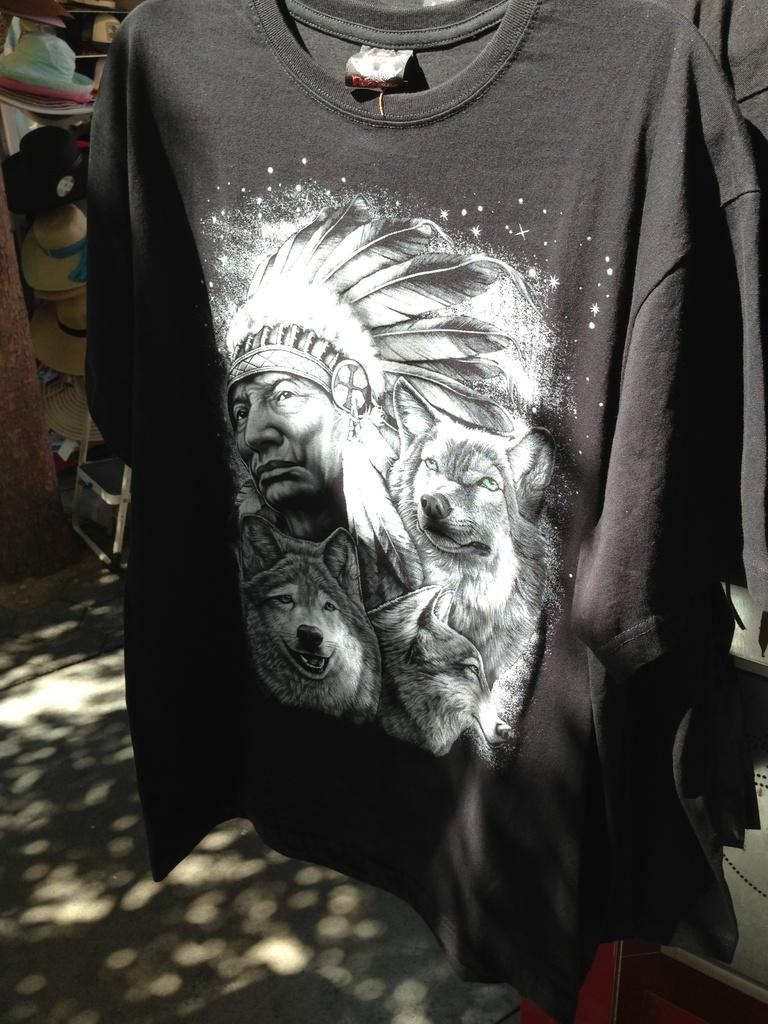What is featured on the t-shirt in the image? There is a design on a t-shirt in the image. What can be seen in the background of the image? There is a group of hats and a chair in the background of the image. What type of organization is being celebrated in the image? There is no indication of an organization or celebration in the image; it only features a t-shirt design and items in the background. How many oranges are visible in the image? There are no oranges present in the image. 